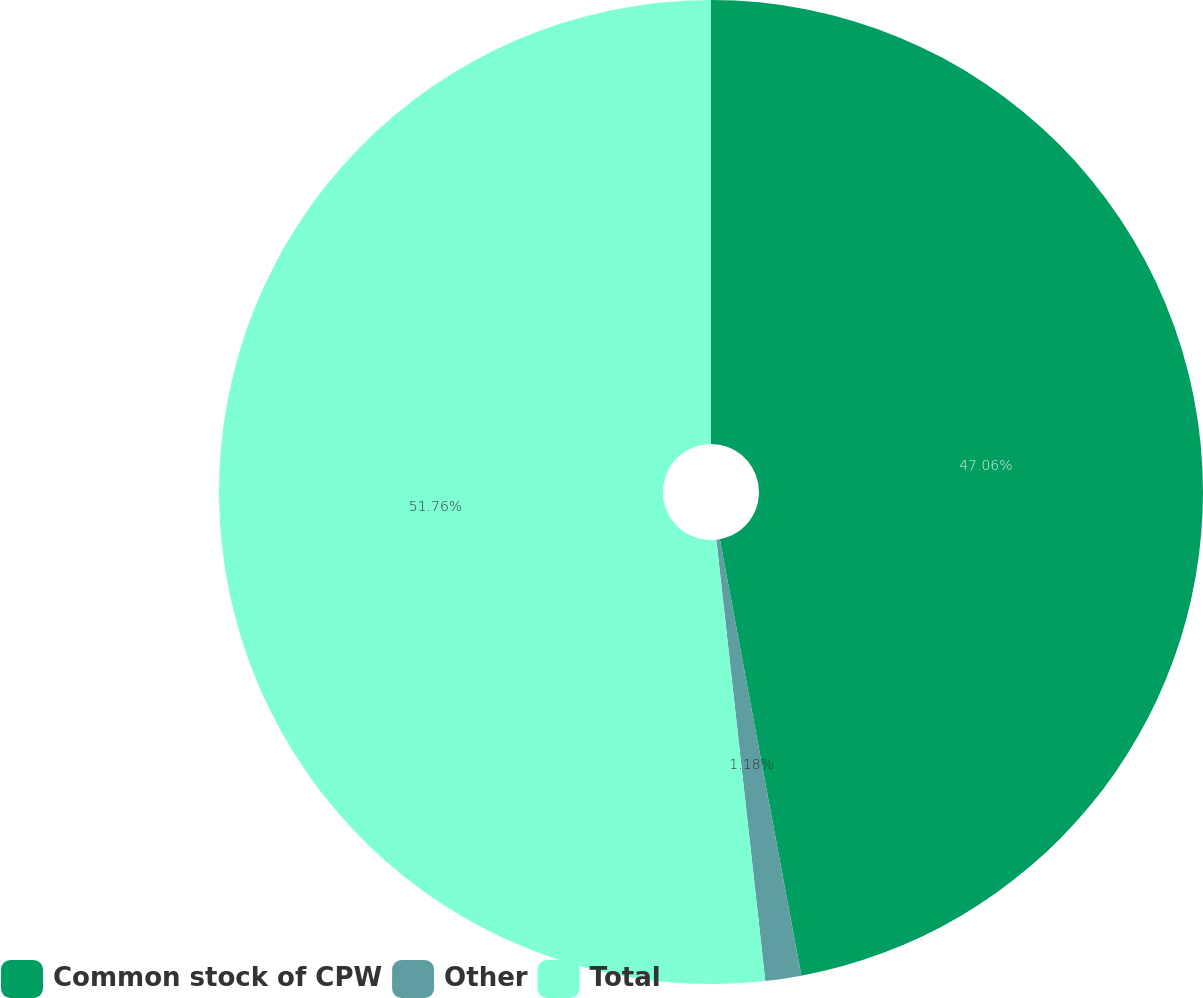Convert chart to OTSL. <chart><loc_0><loc_0><loc_500><loc_500><pie_chart><fcel>Common stock of CPW<fcel>Other<fcel>Total<nl><fcel>47.06%<fcel>1.18%<fcel>51.76%<nl></chart> 